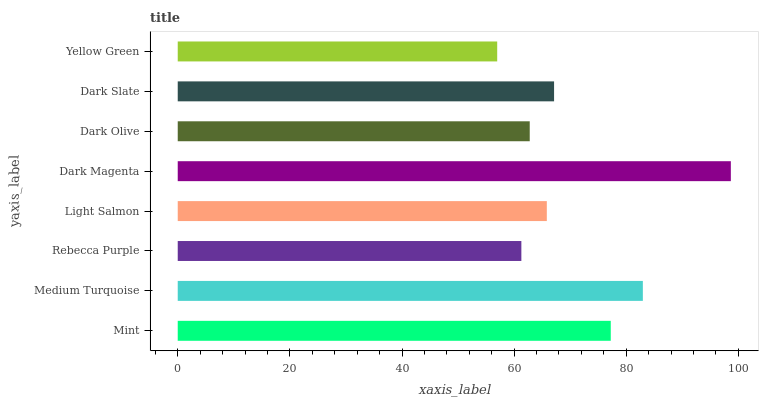Is Yellow Green the minimum?
Answer yes or no. Yes. Is Dark Magenta the maximum?
Answer yes or no. Yes. Is Medium Turquoise the minimum?
Answer yes or no. No. Is Medium Turquoise the maximum?
Answer yes or no. No. Is Medium Turquoise greater than Mint?
Answer yes or no. Yes. Is Mint less than Medium Turquoise?
Answer yes or no. Yes. Is Mint greater than Medium Turquoise?
Answer yes or no. No. Is Medium Turquoise less than Mint?
Answer yes or no. No. Is Dark Slate the high median?
Answer yes or no. Yes. Is Light Salmon the low median?
Answer yes or no. Yes. Is Light Salmon the high median?
Answer yes or no. No. Is Dark Olive the low median?
Answer yes or no. No. 